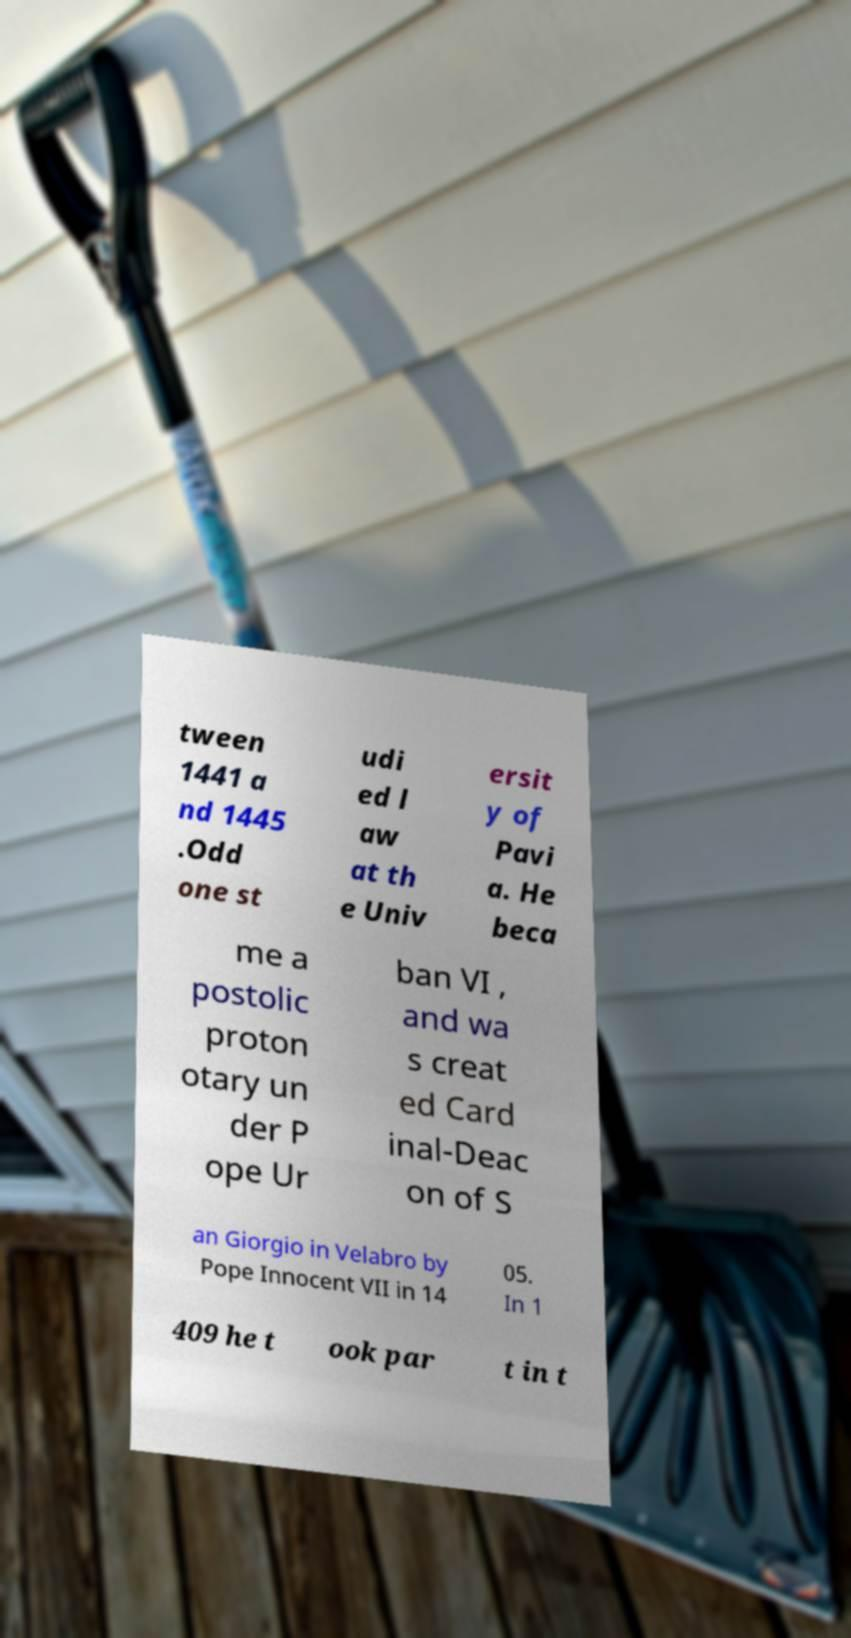What messages or text are displayed in this image? I need them in a readable, typed format. tween 1441 a nd 1445 .Odd one st udi ed l aw at th e Univ ersit y of Pavi a. He beca me a postolic proton otary un der P ope Ur ban VI , and wa s creat ed Card inal-Deac on of S an Giorgio in Velabro by Pope Innocent VII in 14 05. In 1 409 he t ook par t in t 